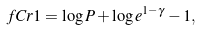Convert formula to latex. <formula><loc_0><loc_0><loc_500><loc_500>\ f C r { 1 } & = \log P + \log e ^ { 1 - \gamma } - 1 ,</formula> 